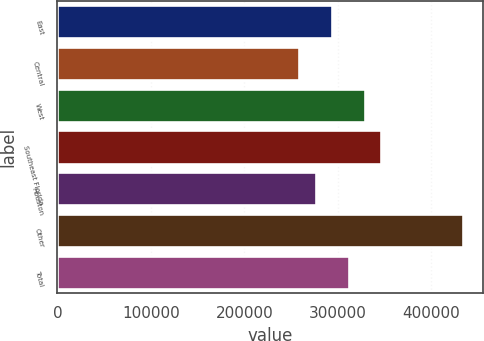Convert chart. <chart><loc_0><loc_0><loc_500><loc_500><bar_chart><fcel>East<fcel>Central<fcel>West<fcel>Southeast Florida<fcel>Houston<fcel>Other<fcel>Total<nl><fcel>294000<fcel>259000<fcel>329000<fcel>346500<fcel>276500<fcel>434000<fcel>311500<nl></chart> 